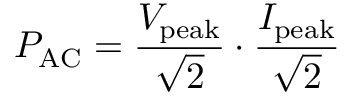Convert formula to latex. <formula><loc_0><loc_0><loc_500><loc_500>P _ { A C } = { \frac { V _ { p e a k } } { \sqrt { 2 } } } \cdot { \frac { I _ { p e a k } } { \sqrt { 2 } } }</formula> 